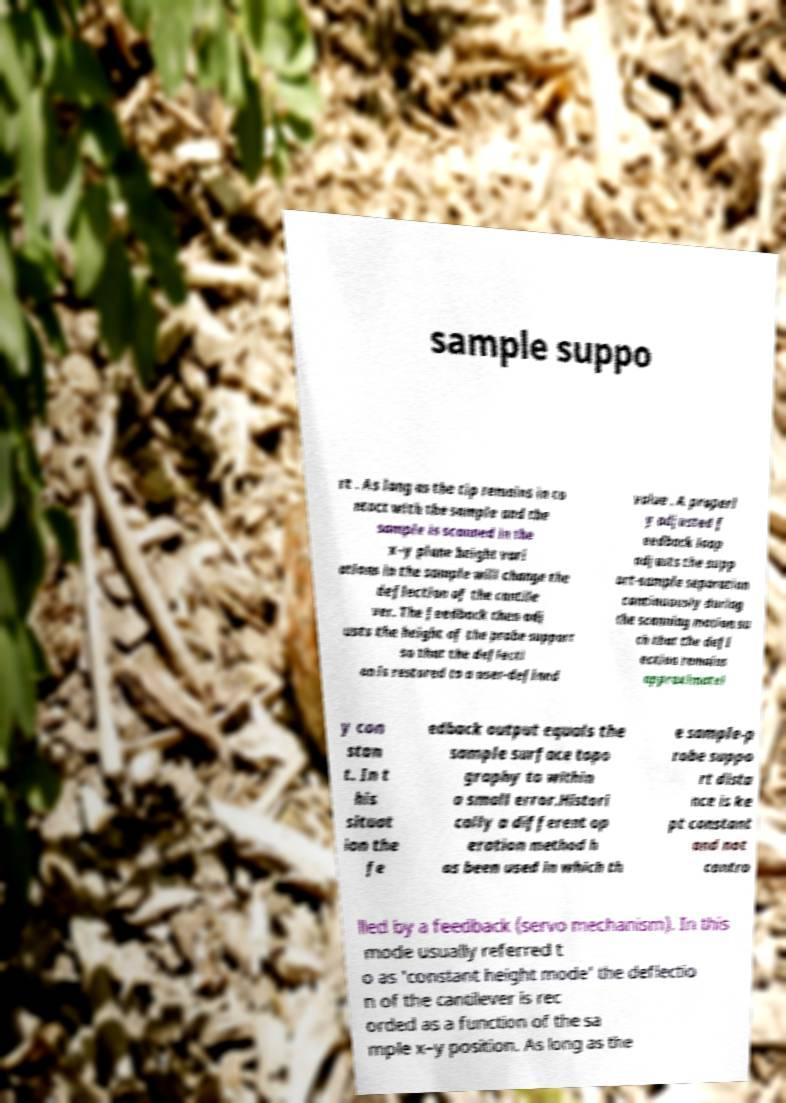Please read and relay the text visible in this image. What does it say? sample suppo rt . As long as the tip remains in co ntact with the sample and the sample is scanned in the x–y plane height vari ations in the sample will change the deflection of the cantile ver. The feedback then adj usts the height of the probe support so that the deflecti on is restored to a user-defined value . A properl y adjusted f eedback loop adjusts the supp ort-sample separation continuously during the scanning motion su ch that the defl ection remains approximatel y con stan t. In t his situat ion the fe edback output equals the sample surface topo graphy to within a small error.Histori cally a different op eration method h as been used in which th e sample-p robe suppo rt dista nce is ke pt constant and not contro lled by a feedback (servo mechanism). In this mode usually referred t o as 'constant height mode' the deflectio n of the cantilever is rec orded as a function of the sa mple x–y position. As long as the 